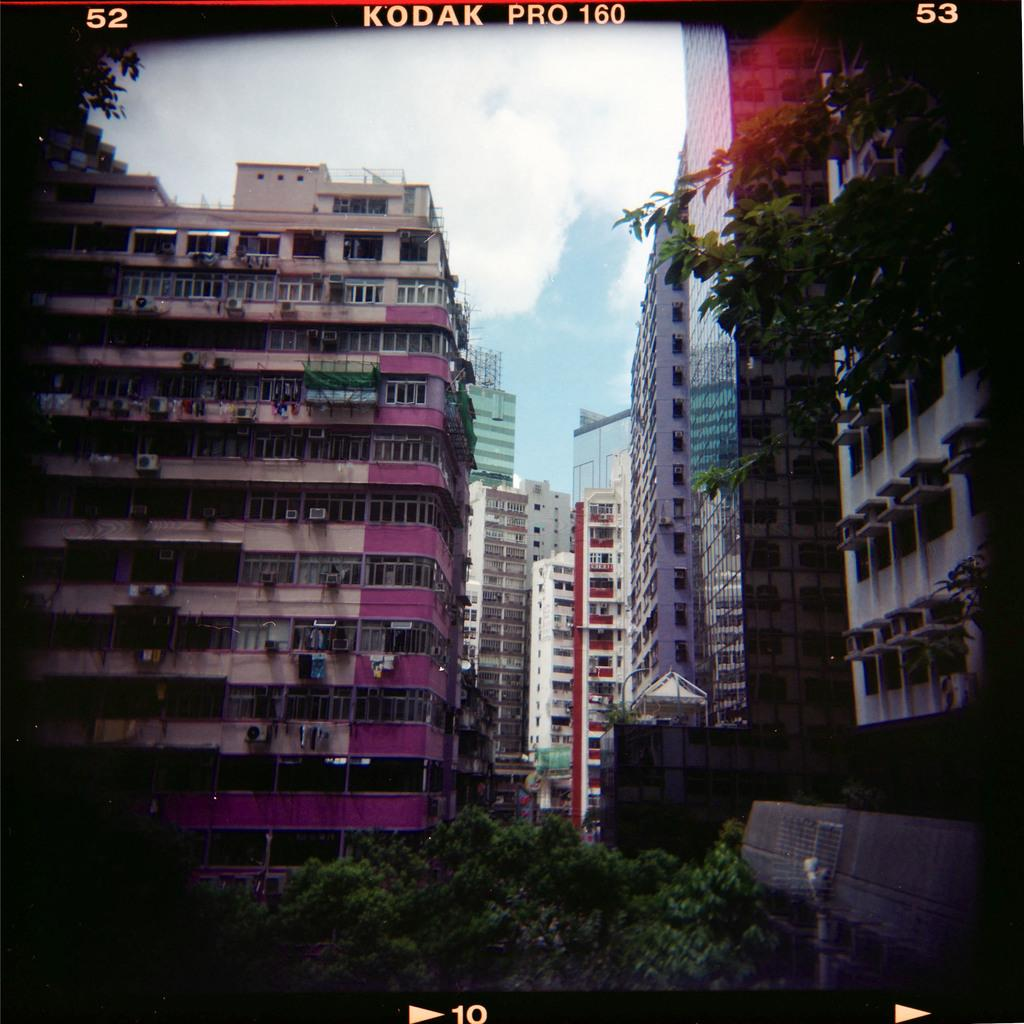What type of structures can be seen in the image? There are buildings in the image. What other natural elements are present in the image? There are trees in the image. What can be seen in the background of the image? The sky is visible in the background of the image. Are there any textual elements in the image? Yes, there are words and numbers on the image. How many bikes are parked near the buildings in the image? There are no bikes present in the image, so it is not possible to determine the number of bikes. 